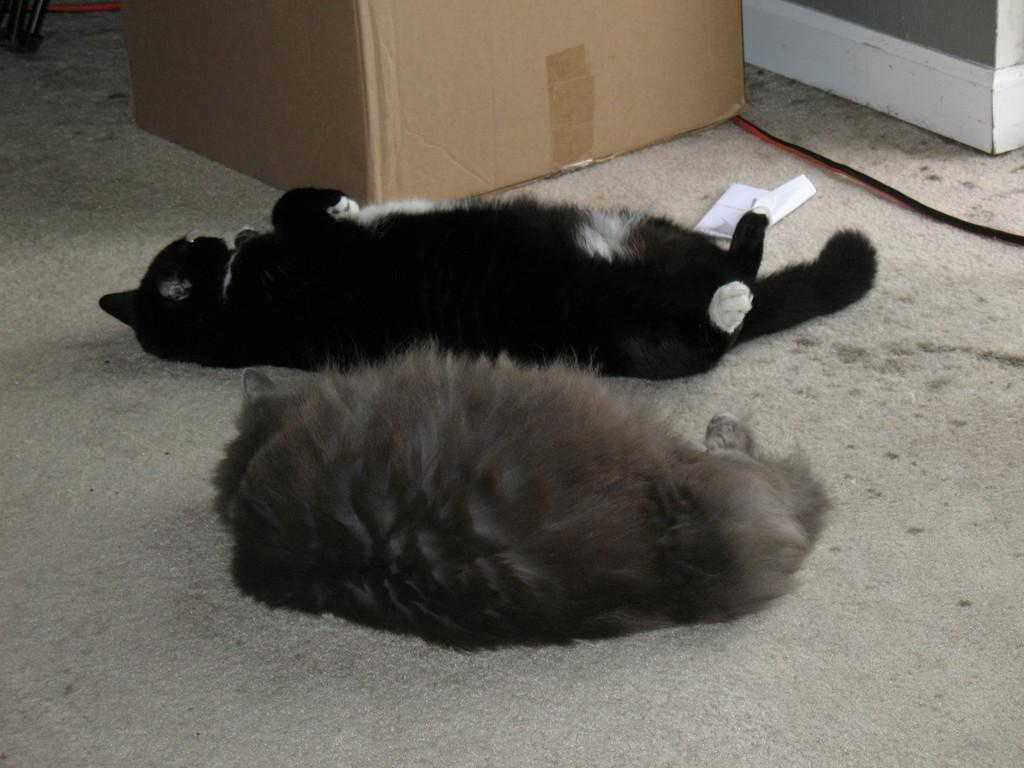How many animals are present in the image? There are two animals in the image. What colors can be seen on the animals? The animals are in brown and black colors. What object can be seen in the background of the image? There is a cardboard box in the background of the image. What colors are present on the wall in the background? The wall in the background is in grey and white colors. What type of crook can be seen holding the scissors in the image? There are no scissors or crooks present in the image. 